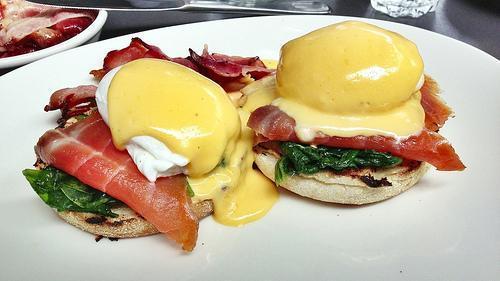How many buns are on the plate?
Give a very brief answer. 2. How many dishes are visible?
Give a very brief answer. 2. 